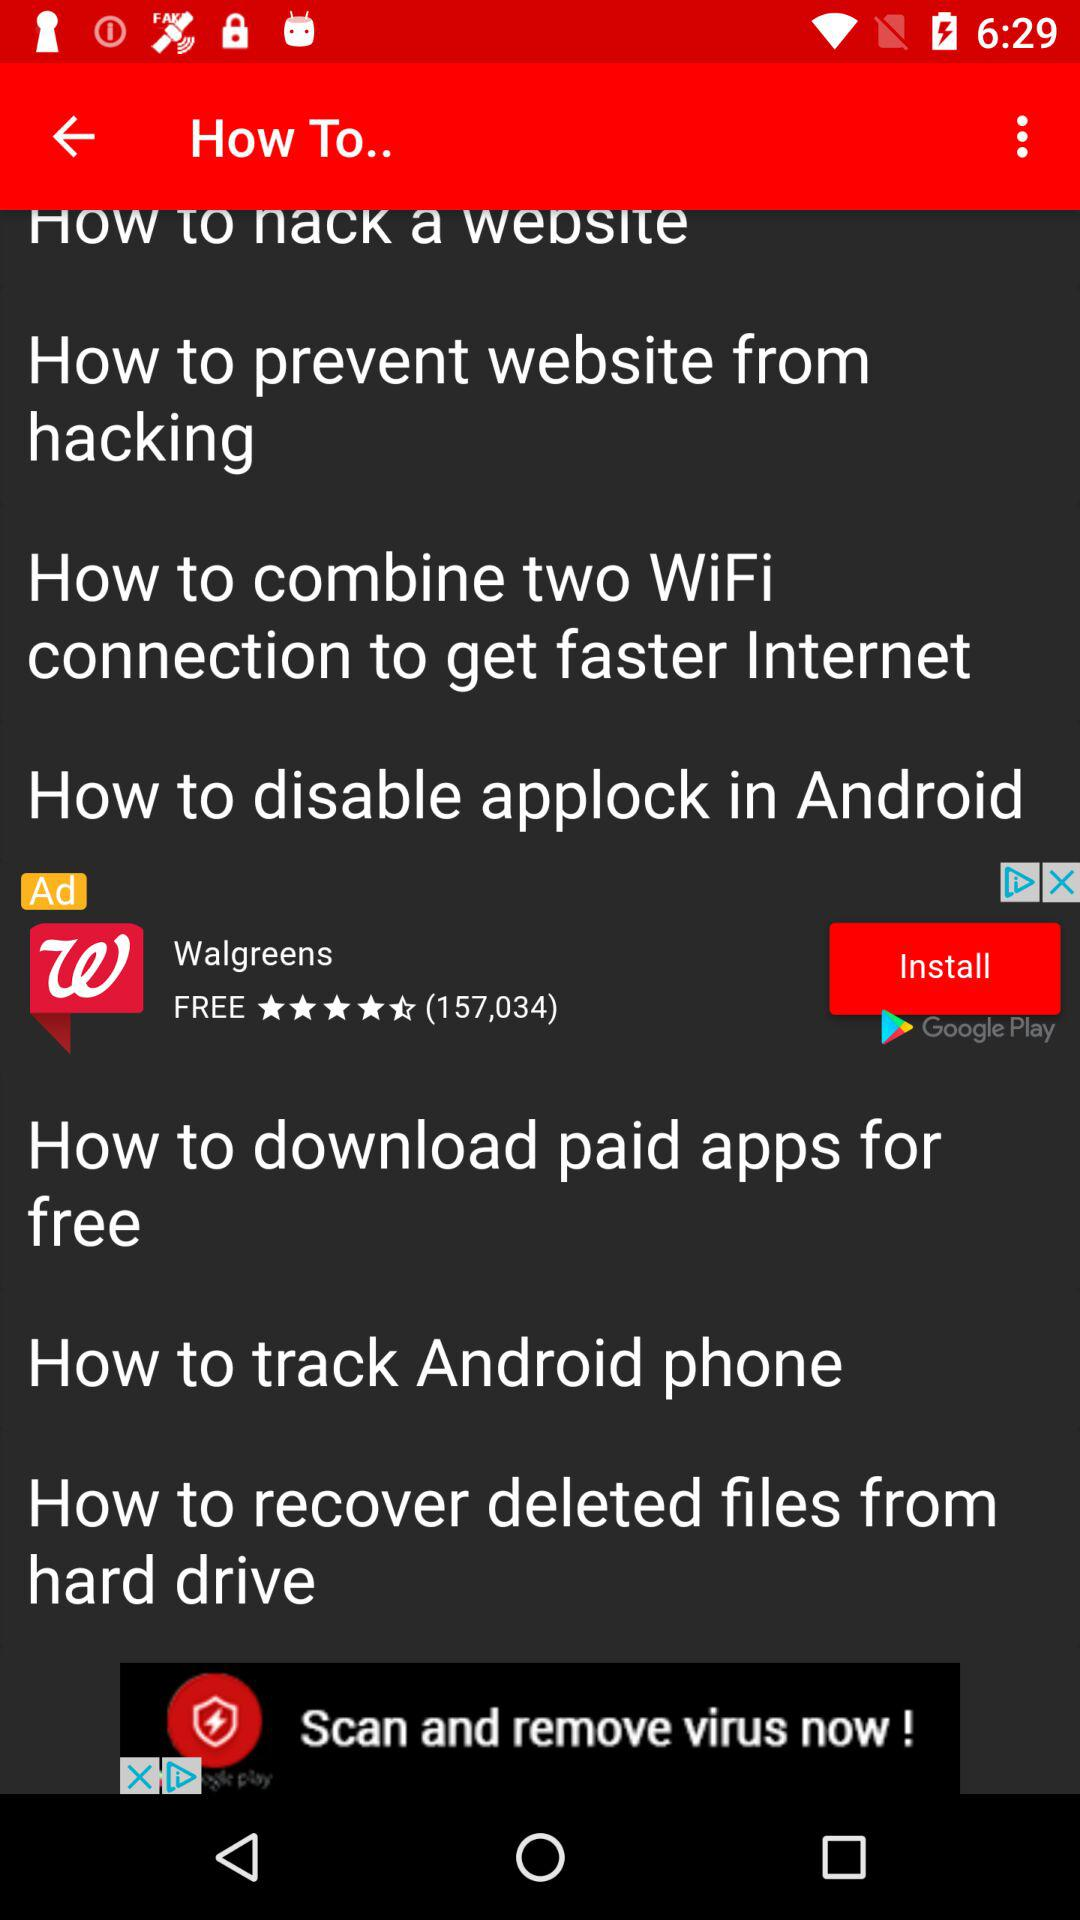How many more how to guides are about hacking than about downloading apps for free?
Answer the question using a single word or phrase. 1 